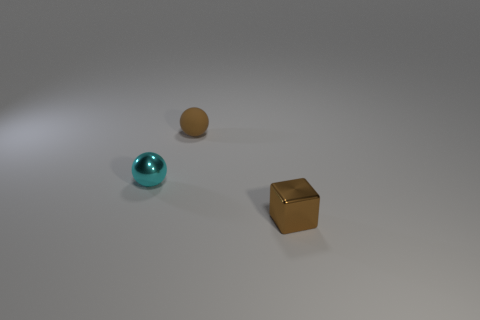There is a brown thing that is the same material as the cyan object; what is its shape?
Give a very brief answer. Cube. Are the cyan ball and the tiny thing that is in front of the cyan sphere made of the same material?
Provide a short and direct response. Yes. Do the tiny metal object on the right side of the rubber object and the rubber object have the same shape?
Provide a short and direct response. No. What material is the other small thing that is the same shape as the cyan shiny thing?
Your answer should be compact. Rubber. There is a small matte object; is its shape the same as the small metallic thing right of the tiny cyan sphere?
Provide a succinct answer. No. What is the color of the object that is in front of the tiny brown rubber thing and to the right of the cyan ball?
Give a very brief answer. Brown. Are any small gray matte things visible?
Make the answer very short. No. Are there the same number of brown spheres that are in front of the brown metal cube and tiny matte balls?
Give a very brief answer. No. What number of other objects are the same shape as the brown metal object?
Make the answer very short. 0. The brown shiny object is what shape?
Give a very brief answer. Cube. 